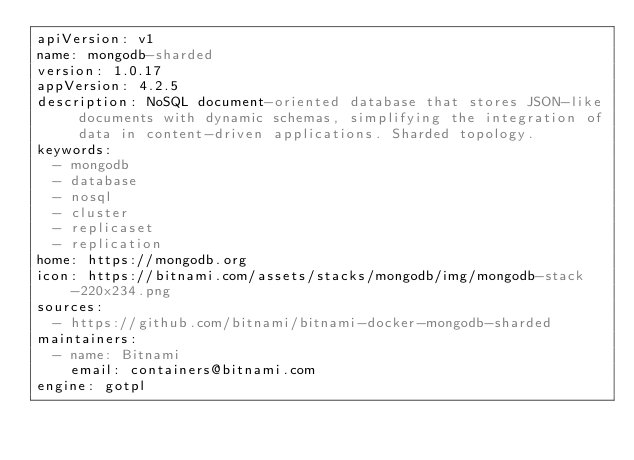Convert code to text. <code><loc_0><loc_0><loc_500><loc_500><_YAML_>apiVersion: v1
name: mongodb-sharded
version: 1.0.17
appVersion: 4.2.5
description: NoSQL document-oriented database that stores JSON-like documents with dynamic schemas, simplifying the integration of data in content-driven applications. Sharded topology.
keywords:
  - mongodb
  - database
  - nosql
  - cluster
  - replicaset
  - replication
home: https://mongodb.org
icon: https://bitnami.com/assets/stacks/mongodb/img/mongodb-stack-220x234.png
sources:
  - https://github.com/bitnami/bitnami-docker-mongodb-sharded
maintainers:
  - name: Bitnami
    email: containers@bitnami.com
engine: gotpl
</code> 